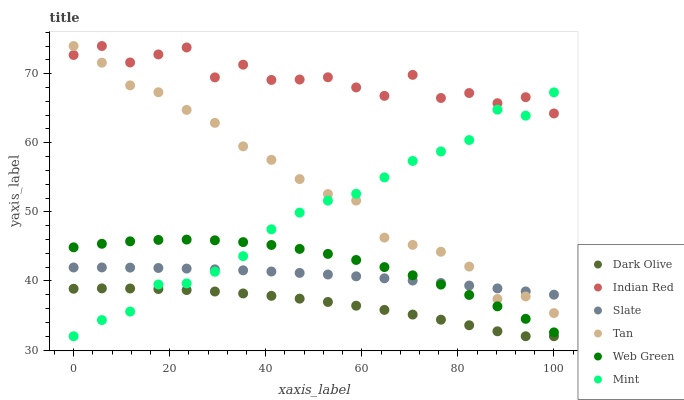Does Dark Olive have the minimum area under the curve?
Answer yes or no. Yes. Does Indian Red have the maximum area under the curve?
Answer yes or no. Yes. Does Web Green have the minimum area under the curve?
Answer yes or no. No. Does Web Green have the maximum area under the curve?
Answer yes or no. No. Is Slate the smoothest?
Answer yes or no. Yes. Is Indian Red the roughest?
Answer yes or no. Yes. Is Dark Olive the smoothest?
Answer yes or no. No. Is Dark Olive the roughest?
Answer yes or no. No. Does Dark Olive have the lowest value?
Answer yes or no. Yes. Does Web Green have the lowest value?
Answer yes or no. No. Does Tan have the highest value?
Answer yes or no. Yes. Does Web Green have the highest value?
Answer yes or no. No. Is Dark Olive less than Slate?
Answer yes or no. Yes. Is Tan greater than Dark Olive?
Answer yes or no. Yes. Does Mint intersect Web Green?
Answer yes or no. Yes. Is Mint less than Web Green?
Answer yes or no. No. Is Mint greater than Web Green?
Answer yes or no. No. Does Dark Olive intersect Slate?
Answer yes or no. No. 